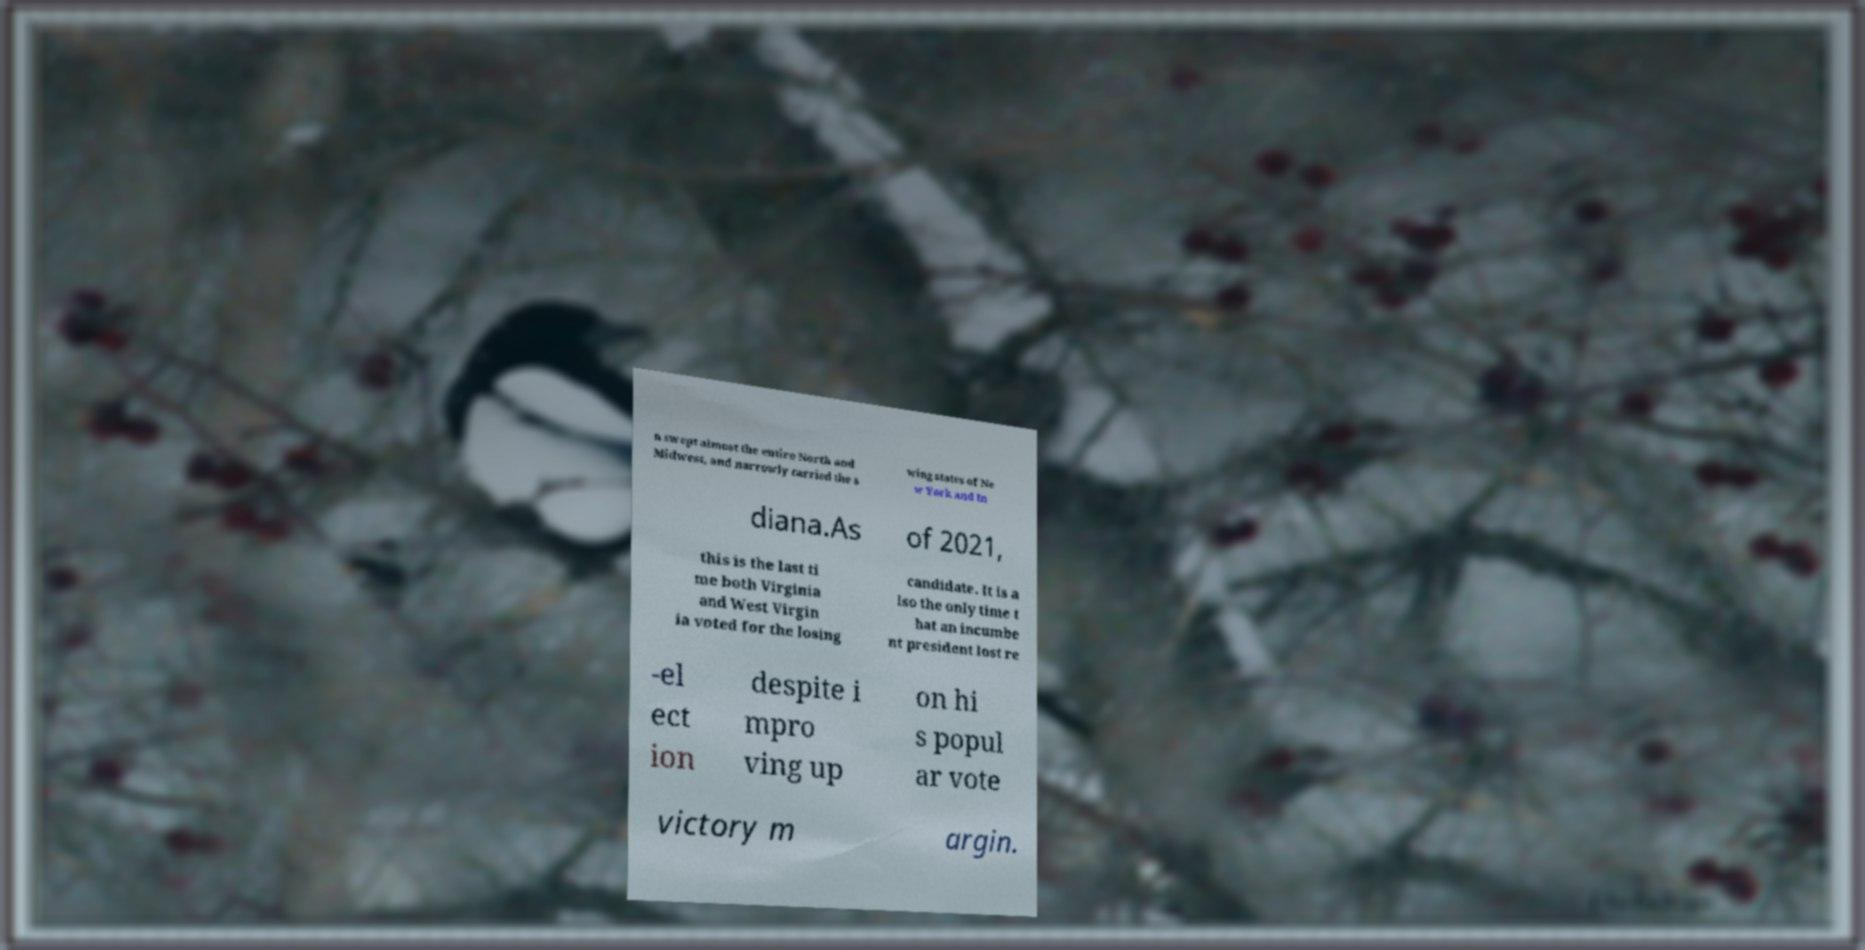What messages or text are displayed in this image? I need them in a readable, typed format. n swept almost the entire North and Midwest, and narrowly carried the s wing states of Ne w York and In diana.As of 2021, this is the last ti me both Virginia and West Virgin ia voted for the losing candidate. It is a lso the only time t hat an incumbe nt president lost re -el ect ion despite i mpro ving up on hi s popul ar vote victory m argin. 